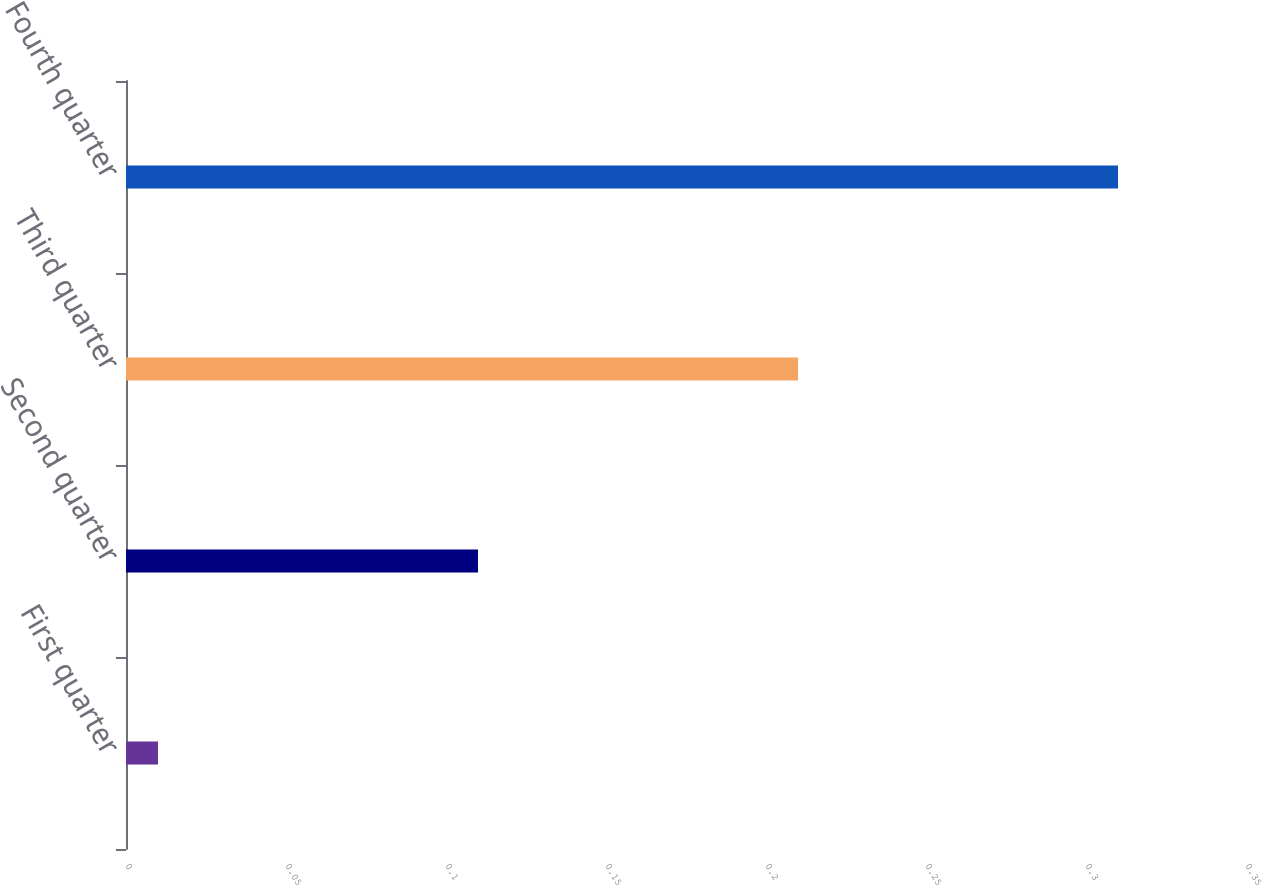<chart> <loc_0><loc_0><loc_500><loc_500><bar_chart><fcel>First quarter<fcel>Second quarter<fcel>Third quarter<fcel>Fourth quarter<nl><fcel>0.01<fcel>0.11<fcel>0.21<fcel>0.31<nl></chart> 